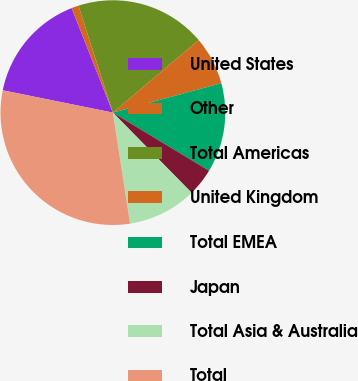<chart> <loc_0><loc_0><loc_500><loc_500><pie_chart><fcel>United States<fcel>Other<fcel>Total Americas<fcel>United Kingdom<fcel>Total EMEA<fcel>Japan<fcel>Total Asia & Australia<fcel>Total<nl><fcel>15.83%<fcel>1.03%<fcel>18.79%<fcel>6.95%<fcel>12.87%<fcel>3.99%<fcel>9.91%<fcel>30.63%<nl></chart> 